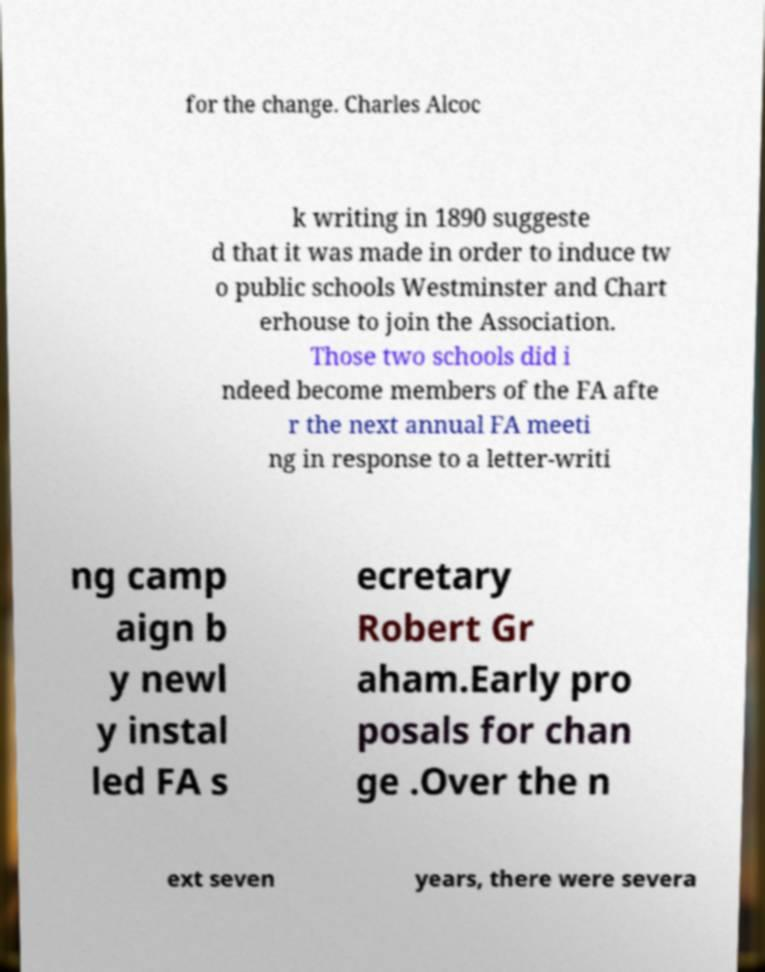There's text embedded in this image that I need extracted. Can you transcribe it verbatim? for the change. Charles Alcoc k writing in 1890 suggeste d that it was made in order to induce tw o public schools Westminster and Chart erhouse to join the Association. Those two schools did i ndeed become members of the FA afte r the next annual FA meeti ng in response to a letter-writi ng camp aign b y newl y instal led FA s ecretary Robert Gr aham.Early pro posals for chan ge .Over the n ext seven years, there were severa 